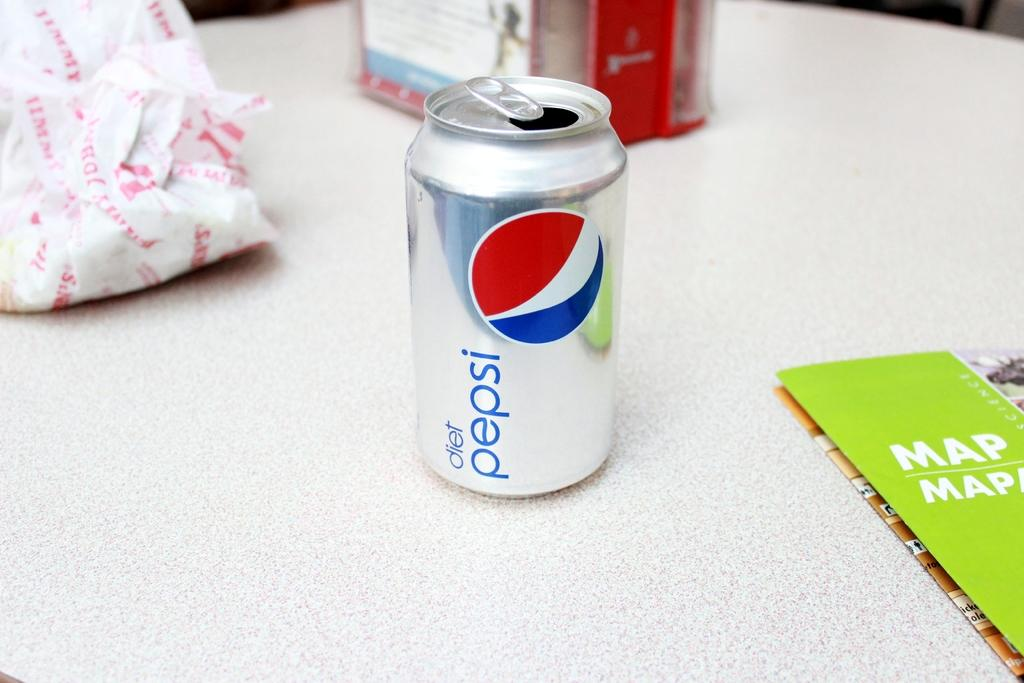<image>
Write a terse but informative summary of the picture. An open can of Diet Pepsi is on a table next to a map and a Jimmy John sandwich wrapper. 